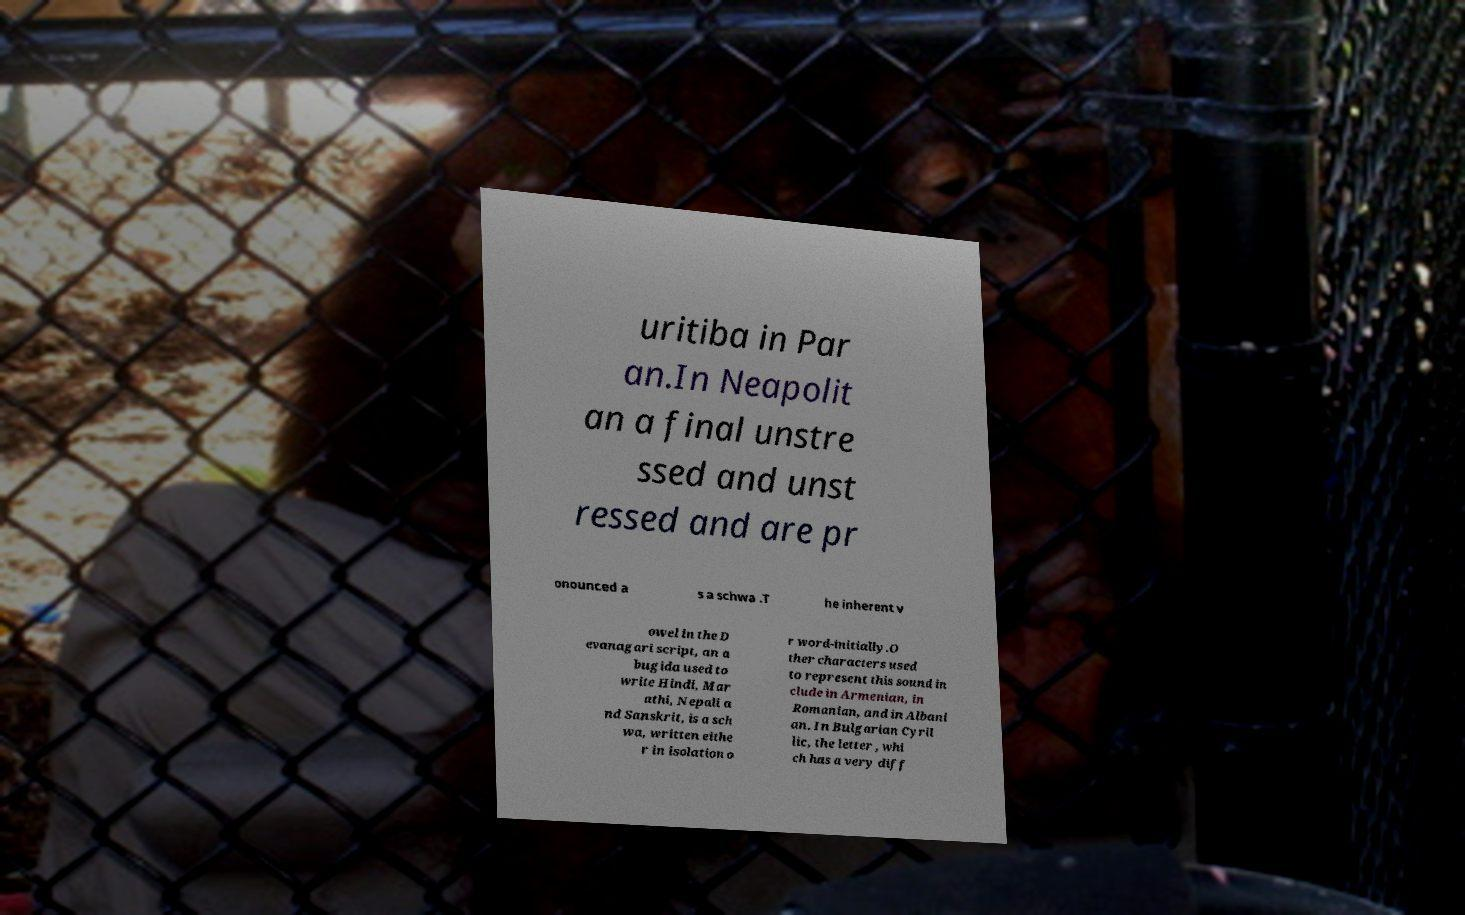I need the written content from this picture converted into text. Can you do that? uritiba in Par an.In Neapolit an a final unstre ssed and unst ressed and are pr onounced a s a schwa .T he inherent v owel in the D evanagari script, an a bugida used to write Hindi, Mar athi, Nepali a nd Sanskrit, is a sch wa, written eithe r in isolation o r word-initially.O ther characters used to represent this sound in clude in Armenian, in Romanian, and in Albani an. In Bulgarian Cyril lic, the letter , whi ch has a very diff 